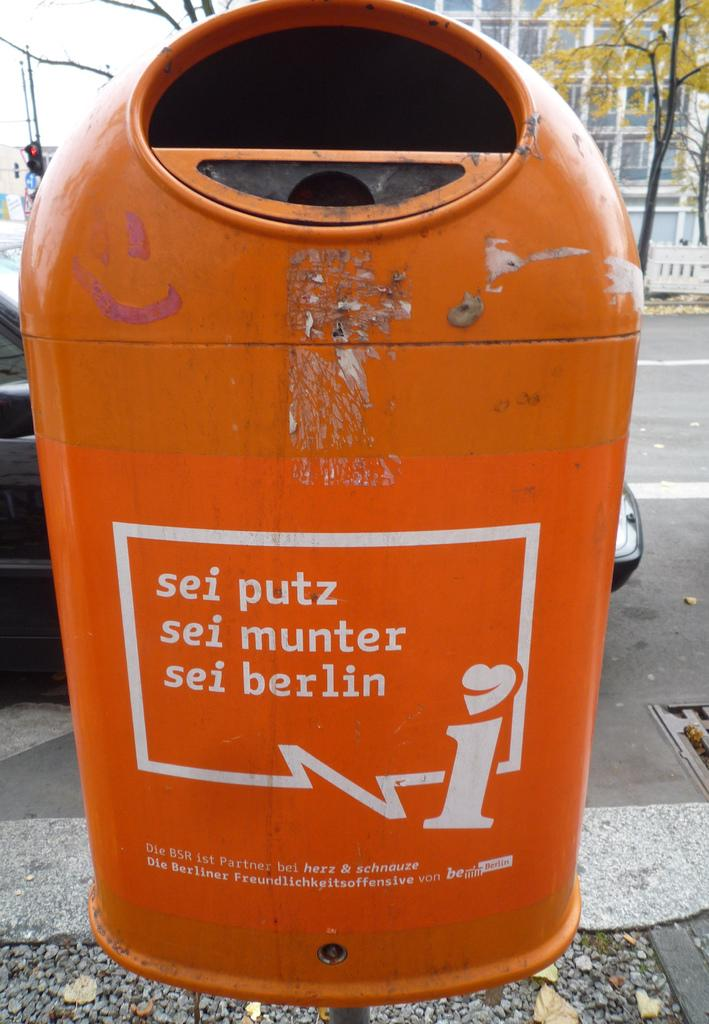<image>
Present a compact description of the photo's key features. A recycling bin sits on a sidewalk in Berlin. 